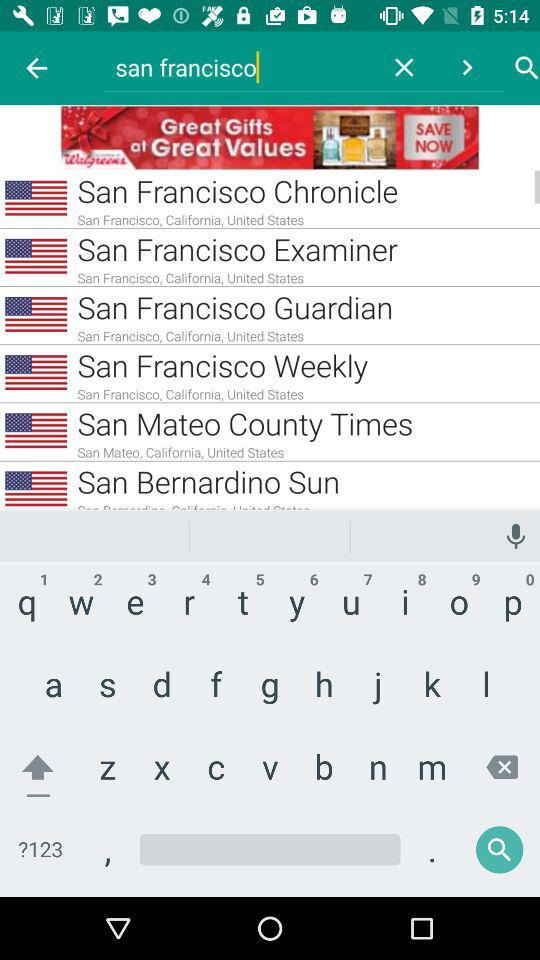What is the username?
When the provided information is insufficient, respond with <no answer>. <no answer> 